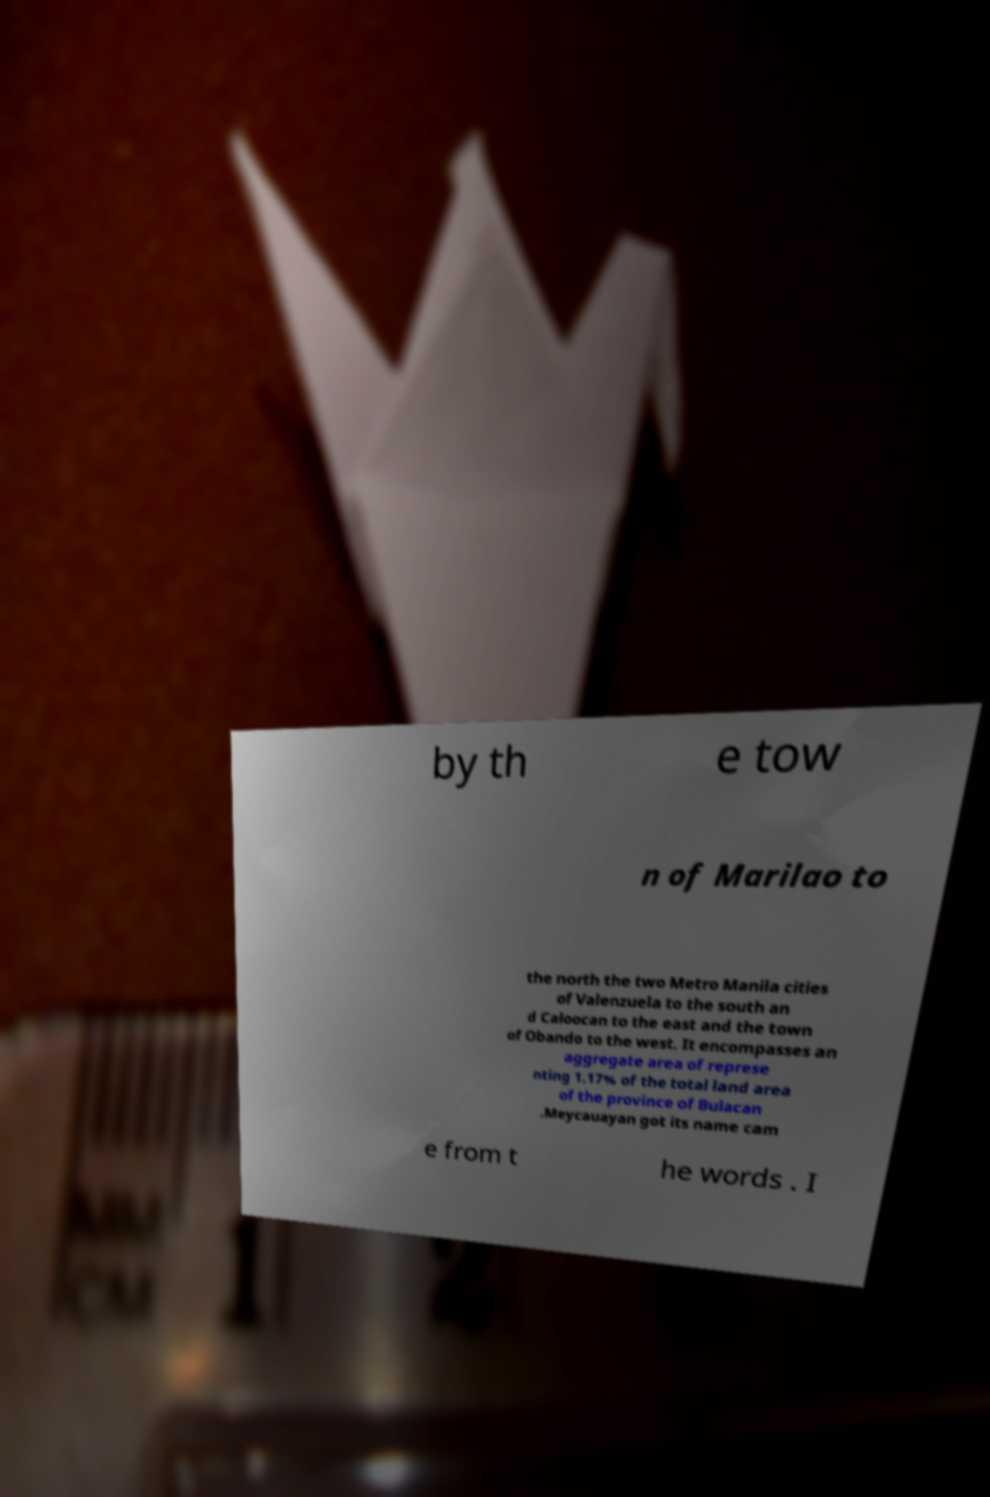Could you assist in decoding the text presented in this image and type it out clearly? by th e tow n of Marilao to the north the two Metro Manila cities of Valenzuela to the south an d Caloocan to the east and the town of Obando to the west. It encompasses an aggregate area of represe nting 1.17% of the total land area of the province of Bulacan .Meycauayan got its name cam e from t he words . I 